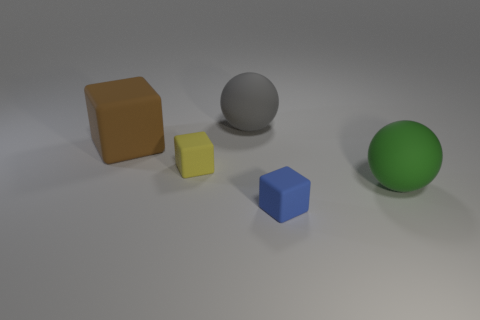Can you tell me about the colors of the objects? Certainly! In the image, we see objects with a variety of colors. From left to right, there is a brown cube, a yellow smaller cube, a grey sphere, and a green sphere. These objects are arranged against a neutral gray background, which makes their colors stand out more vividly. 